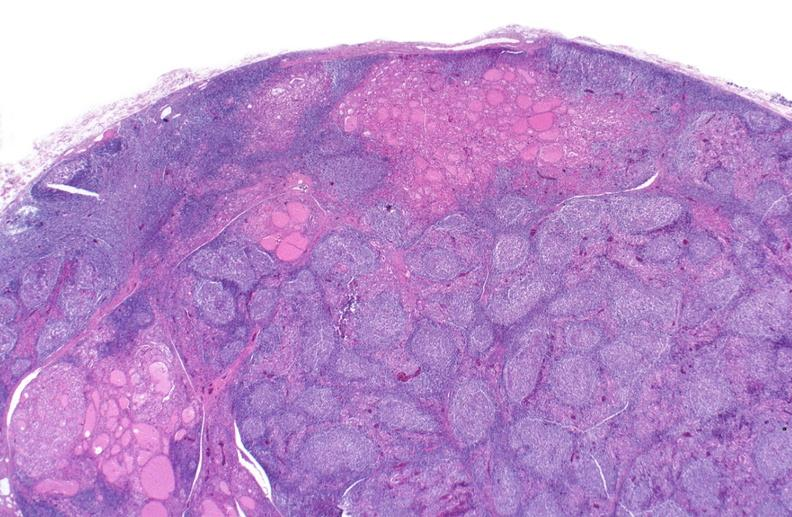where is this part in the figure?
Answer the question using a single word or phrase. Endocrine system 